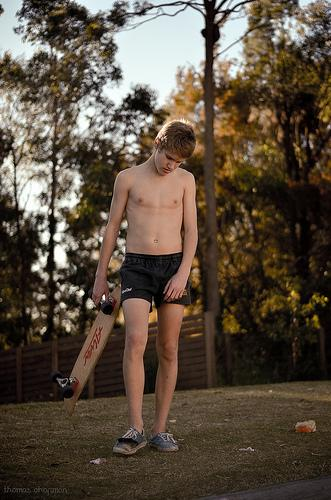Is there anything special about the boy's shoes? Describe their condition. Yes, the boy's tennis shoes are tattered, dirty, and torn up, suggesting extensive use or damage. Can you infer the time of year based on the description of the image? If so, what is it? It's likely a summer day, given the boy is not wearing a shirt and is walking outdoors with green trees in the background. Are there any notable objects on the ground near the boy? If so, describe them. Yes, there is trash on the ground near the boy, possibly at the side of a paved road. Describe the skateboard the boy is holding and mention its materials and colors. The skateboard is brown and red, made of wood with black wheels, suggesting it's a sturdy and well-constructed item. Count the number of unique objects mentioned in the image and provide the total count. There are 15 unique objects mentioned in the image. Evaluate the image sentiment and provide a brief explanation.  The image sentiment is slightly negative, as the boy seems sad and there's trash on the ground, hinting at neglect or disrepair. Identify the primary activity of the boy in the image. The boy is walking while holding a skateboard in his right hand and looking at his shoes. Mention one object found behind the boy and describe its characteristics. There's a wooden fence by the trees with a brown color, appearing to surround the area where the boy is walking. Is the boy wearing any top clothing? What about his lower apparels? The boy is not wearing a shirt, but he is wearing black shorts. What emotions can be inferred from the boy's appearance in the image? The boy appears to be sad or disappointed, possibly due to his torn shoes or a failed skateboarding attempt. What is the color of the boy's sneakers? Blue Is the boy wearing a shirt? Choose an answer from the options provided: a) Yes, b) No b) No What material is the skateboard made of? The skateboard is made of wood. Identify the type of activity the boy is engaged in. The boy is walking and carrying a skateboard. Identify any emotions or feelings that the boy might be experiencing in the image. The boy might be feeling sad or disappointed. Mention a few items found in the background. There are green trees, a wooden fence, and some trash on the ground. In the image, describe the type of terrain or environment the boy is in. The boy is in a grassy area with trees and a wooden fence in the background. What is the state of the grass in the image? The grass is short and mowed. Is there any trash visible in the image? If so, where is it located? Yes, there is trash on the ground near the grass. Can you provide a multi-modal creation to summarize this image and its elements? A boy walks barefoot on a summer day, carrying a wooden skateboard with black wheels. He is wearing black shorts, and his blue sneakers are torn up. The setting includes a grassy area with trash, a wooden fence, and trees in the background. What is behind the wooden fence in the image? There are trees behind the fence. Describe the condition of the boy's shoes in the image. The boy's shoes are tattered and dirty. What is the weather like in the image? It is a sunny day. Can you describe the sunlight coming through the trees? The sunlight is filtering through the trees, creating dappled shadows on the ground. What is the color of the boy's shorts? Black Describe the skateboard's wheels. The skateboard wheels are black. Is the skateboarder wearing a shirt in the image? No, the skateboarder is shirtless. What is the boy holding in his hand? A skateboard 